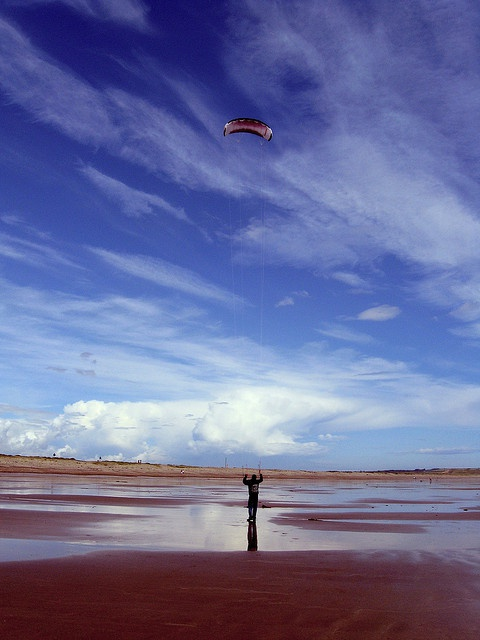Describe the objects in this image and their specific colors. I can see kite in navy, black, and purple tones and people in navy, black, gray, and maroon tones in this image. 